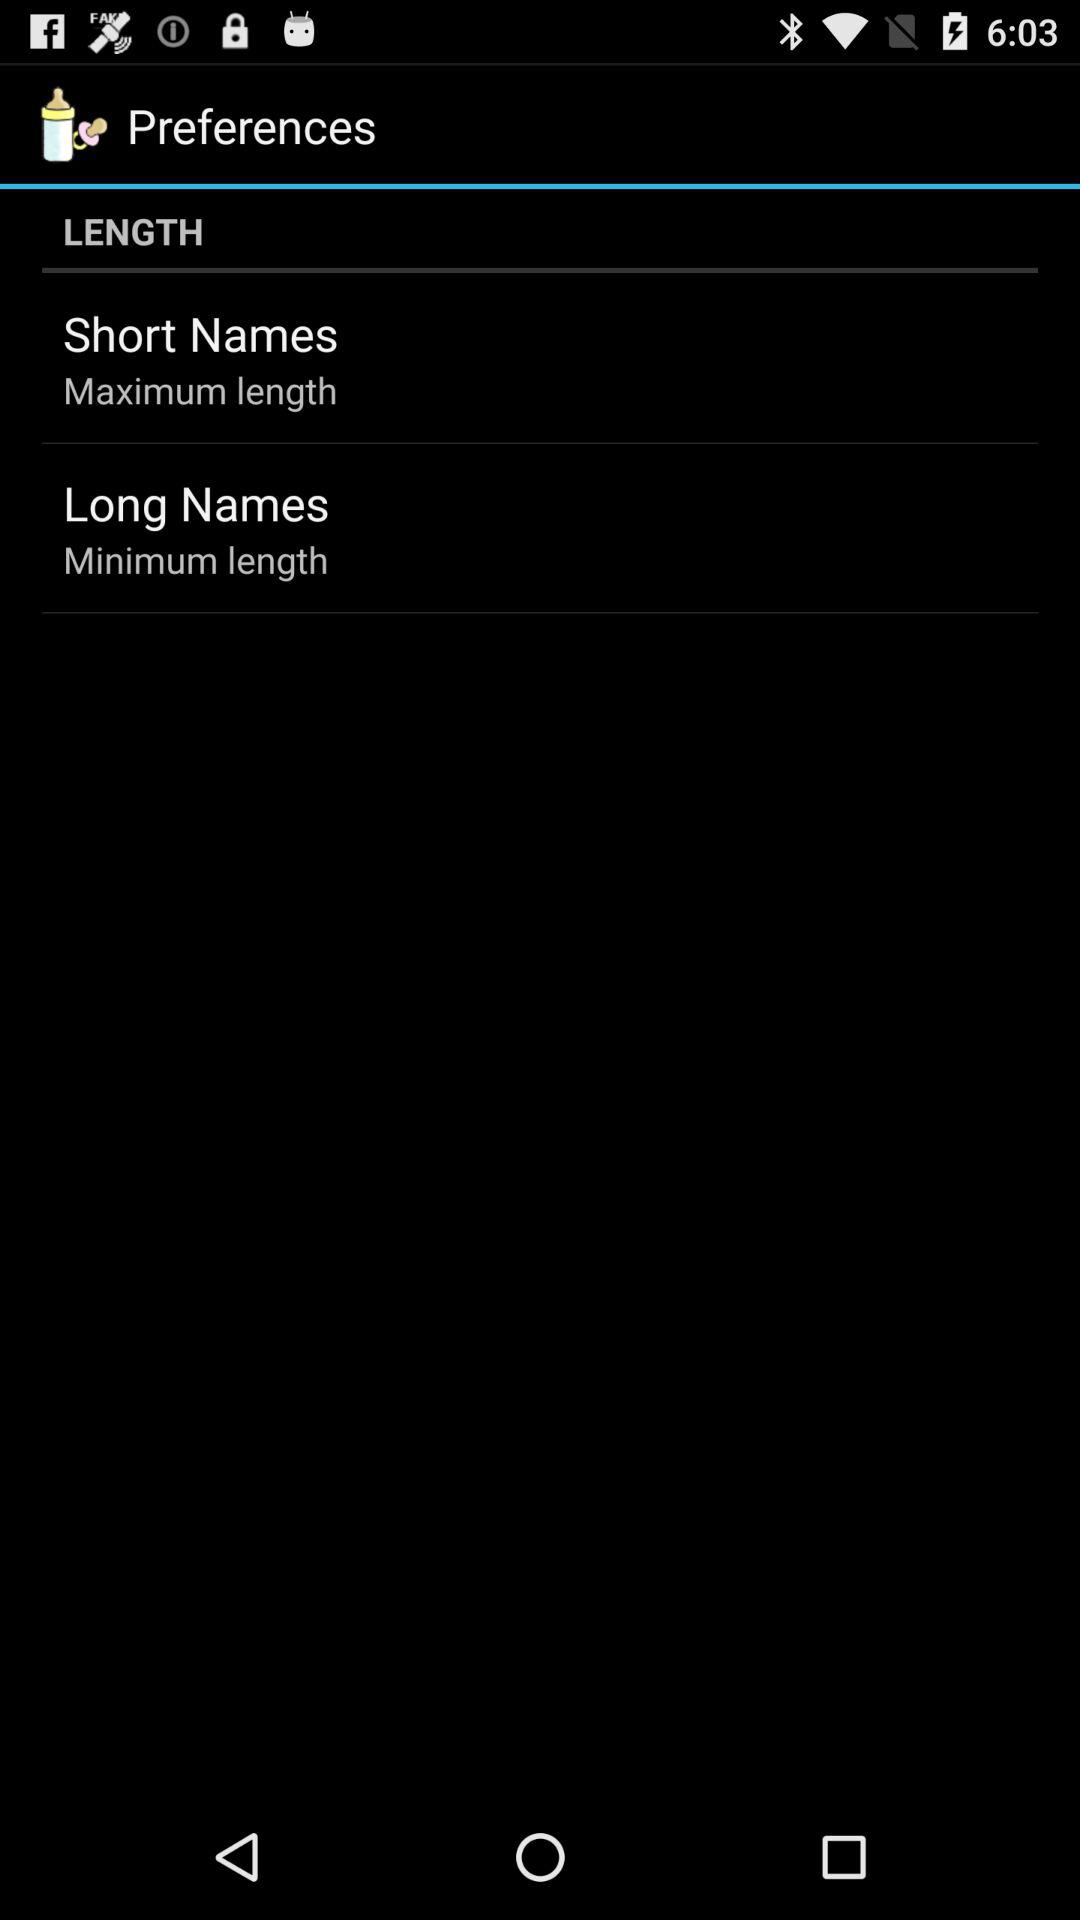What is the length of "Short Names"? The length is maximum. 